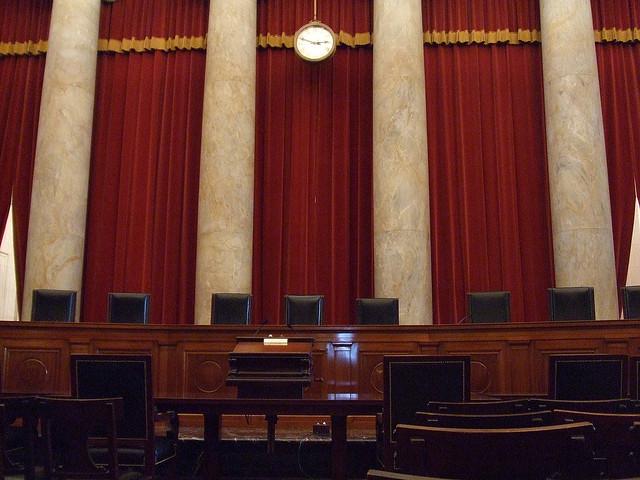What time is it?
Keep it brief. 2:50. What is hanging on the back wall?
Quick response, please. Clock. Is this a conference room?
Be succinct. Yes. What kind of room is this?
Answer briefly. Courtroom. What color are the seats?
Short answer required. Black. 